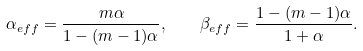Convert formula to latex. <formula><loc_0><loc_0><loc_500><loc_500>\alpha _ { e f f } = \frac { m \alpha } { 1 - ( m - 1 ) \alpha } , \quad \beta _ { e f f } = \frac { 1 - ( m - 1 ) \alpha } { 1 + \alpha } .</formula> 